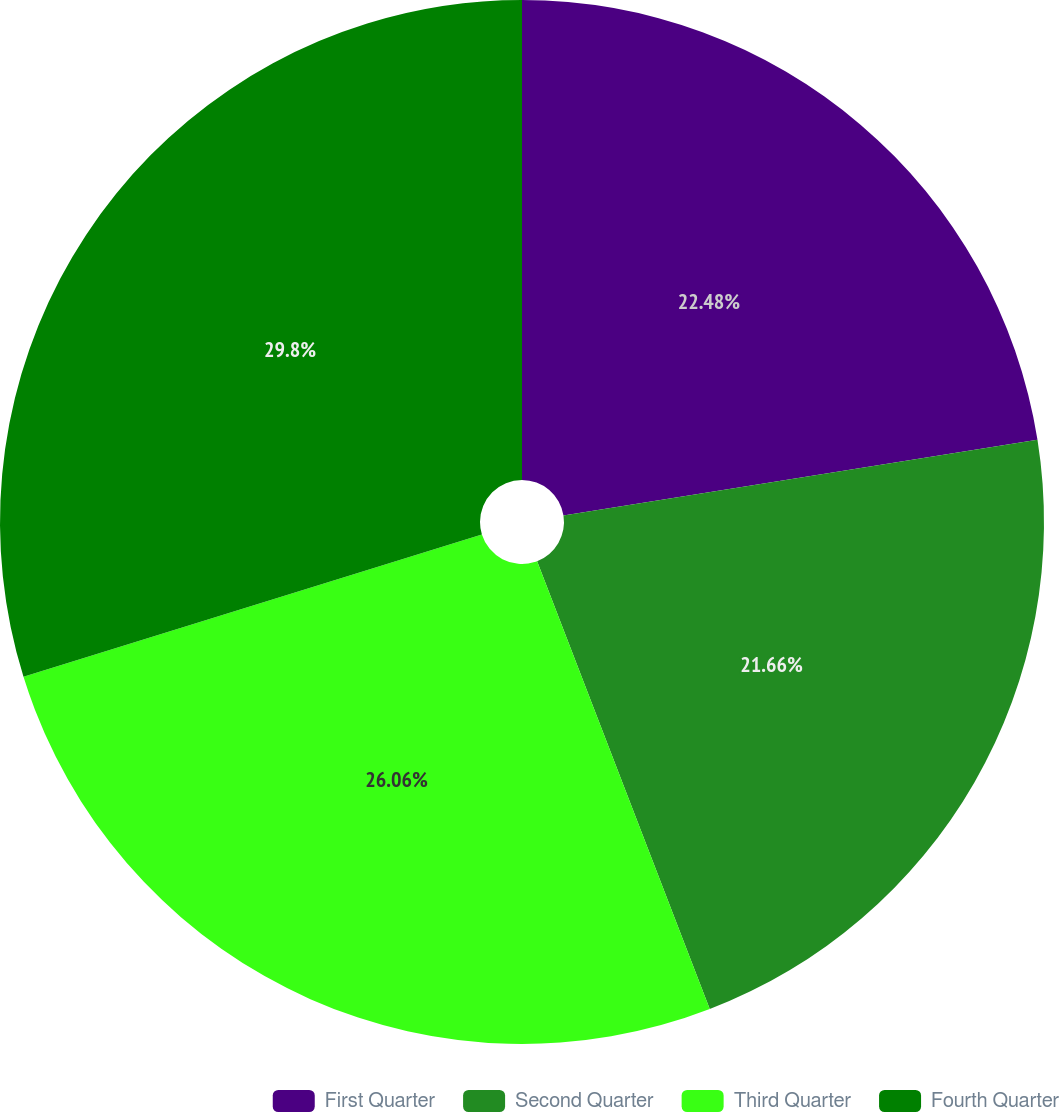Convert chart to OTSL. <chart><loc_0><loc_0><loc_500><loc_500><pie_chart><fcel>First Quarter<fcel>Second Quarter<fcel>Third Quarter<fcel>Fourth Quarter<nl><fcel>22.48%<fcel>21.66%<fcel>26.06%<fcel>29.79%<nl></chart> 